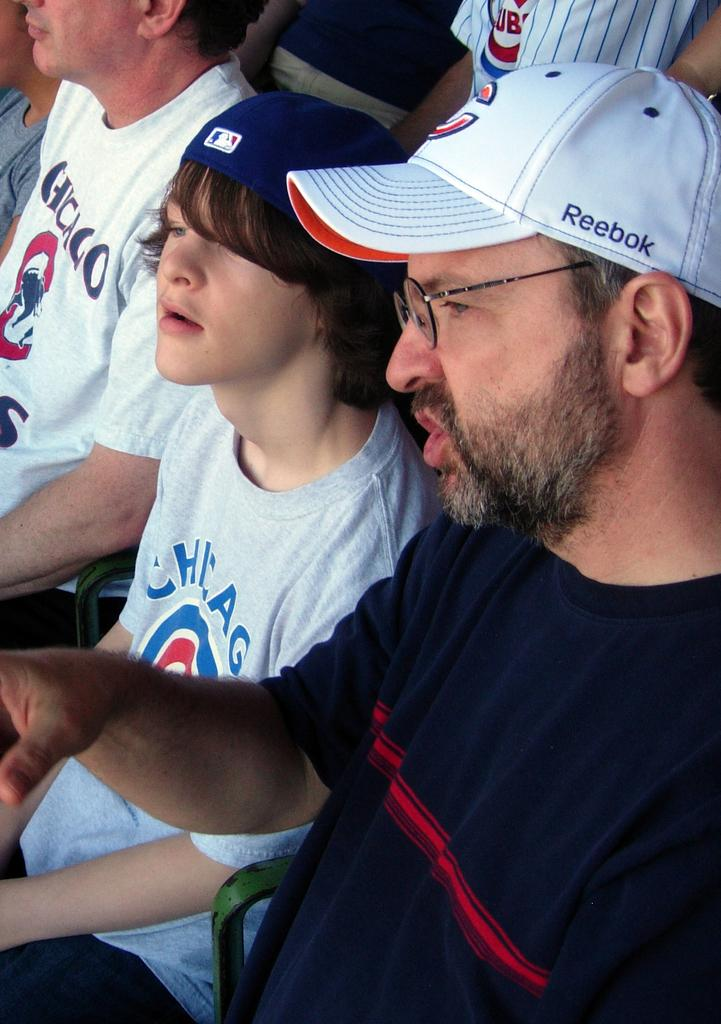<image>
Relay a brief, clear account of the picture shown. A boy wearing a Chiago cubs shirt sitting next to a bespectacled man 